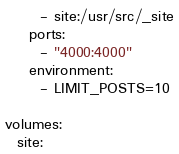<code> <loc_0><loc_0><loc_500><loc_500><_YAML_>      - site:/usr/src/_site
    ports:
      - "4000:4000"
    environment:
      - LIMIT_POSTS=10

volumes:
  site:</code> 